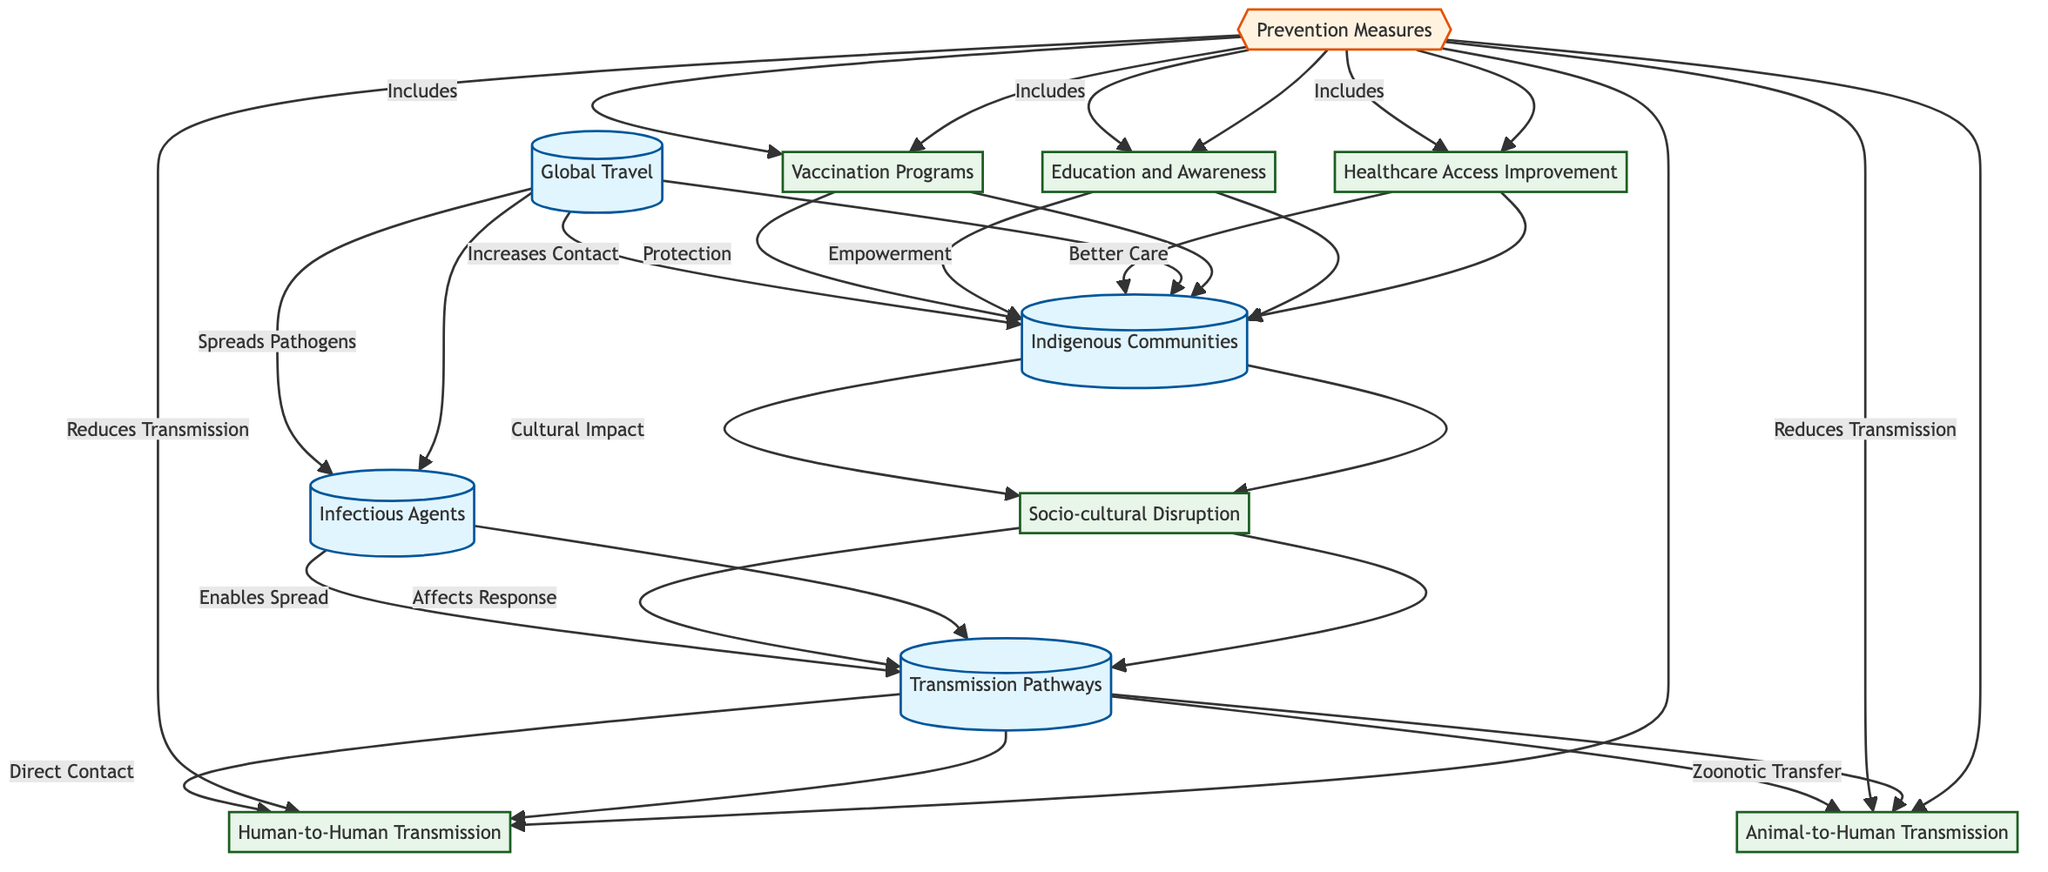What is the primary source of increased contact with indigenous communities? The diagram indicates "Global Travel" as the primary source through which contact with indigenous communities is increased. This is highlighted by the direct connection from the node of Global Travel to Indigenous Communities.
Answer: Global Travel How many distinct transmission pathways are identified in the diagram? The diagram shows two distinct transmission pathways: "Human-to-Human Transmission" and "Animal-to-Human Transmission" connected to the "Transmission Pathways" node.
Answer: 2 What type of impact does the increase in global interactions have on indigenous communities? The diagram illustrates that increased global interactions lead to "Cultural Impact" on indigenous communities, as indicated by the connection from Indigenous Communities to Socio-cultural Disruption.
Answer: Cultural Impact Which prevention measure is mentioned as providing "Better Care" to indigenous communities? The prevention measure "Healthcare Access Improvement" is the one mentioned as providing "Better Care" according to the connections shown in the diagram from Prevention Measures to Healthcare Access Improvement.
Answer: Healthcare Access Improvement What does "Education and Awareness" contribute to indigenous communities? "Education and Awareness" is linked to the empowerment of indigenous communities, as indicated in the diagram where this prevention measure connects to the communities under Prevention Measures.
Answer: Empowerment How does "Socio-cultural Disruption" affect the transmission pathways? The diagram shows that "Socio-cultural Disruption" affects the response to transmission pathways by creating a feedback loop, impacting how diseases are transmitted among indigenous communities.
Answer: Affects Response What role does "Vaccination Programs" play in disease transmission? In the diagram, "Vaccination Programs" is part of the prevention measures that reduce transmission through protection, thereby directly impacting disease spread in indigenous communities as represented by the links from Prevention Measures to Vaccination Programs.
Answer: Protection How are "Infectious Agents" spread according to the diagram? The diagram indicates that Infectious Agents are spread through "Global Travel", which shows a direct connection feeding into how pathogens reach indigenous communities.
Answer: Spreads Pathogens 